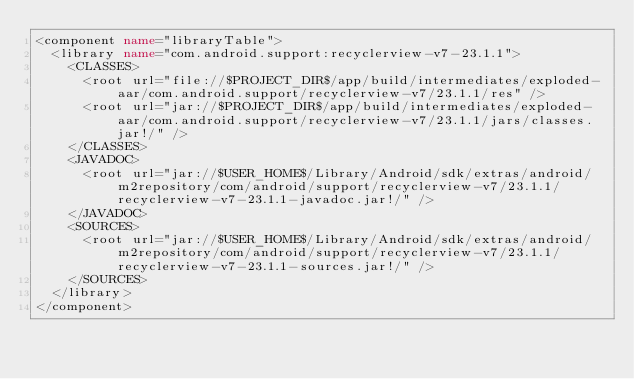Convert code to text. <code><loc_0><loc_0><loc_500><loc_500><_XML_><component name="libraryTable">
  <library name="com.android.support:recyclerview-v7-23.1.1">
    <CLASSES>
      <root url="file://$PROJECT_DIR$/app/build/intermediates/exploded-aar/com.android.support/recyclerview-v7/23.1.1/res" />
      <root url="jar://$PROJECT_DIR$/app/build/intermediates/exploded-aar/com.android.support/recyclerview-v7/23.1.1/jars/classes.jar!/" />
    </CLASSES>
    <JAVADOC>
      <root url="jar://$USER_HOME$/Library/Android/sdk/extras/android/m2repository/com/android/support/recyclerview-v7/23.1.1/recyclerview-v7-23.1.1-javadoc.jar!/" />
    </JAVADOC>
    <SOURCES>
      <root url="jar://$USER_HOME$/Library/Android/sdk/extras/android/m2repository/com/android/support/recyclerview-v7/23.1.1/recyclerview-v7-23.1.1-sources.jar!/" />
    </SOURCES>
  </library>
</component></code> 